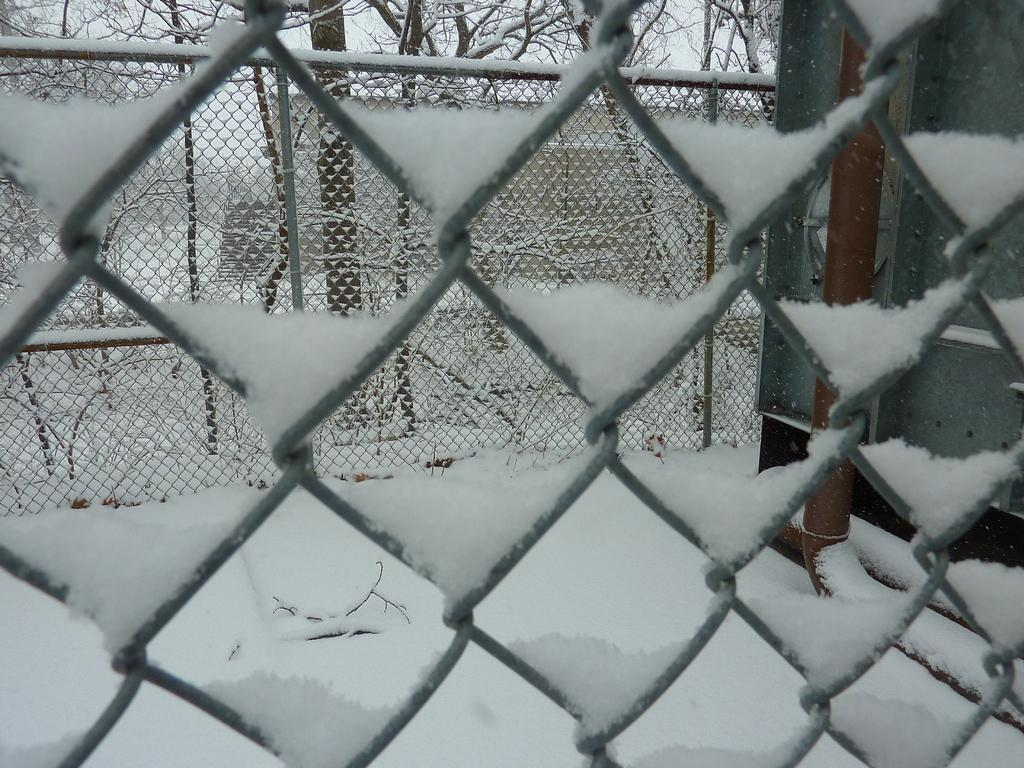What is the main subject of the image? The main subject of the image is a grill fencing net full of snow. Are there any other grill fencing nets visible in the image? Yes, there is another grill fencing net with pipes visible in the image. What can be seen behind the grill fencing net with pipes? Dry trees are present behind the grill fencing net with pipes. Where is the desk located in the image? There is no desk present in the image. What type of jelly can be seen on the grill fencing net with pipes? There is no jelly present on the grill fencing net with pipes; it is covered in snow. 